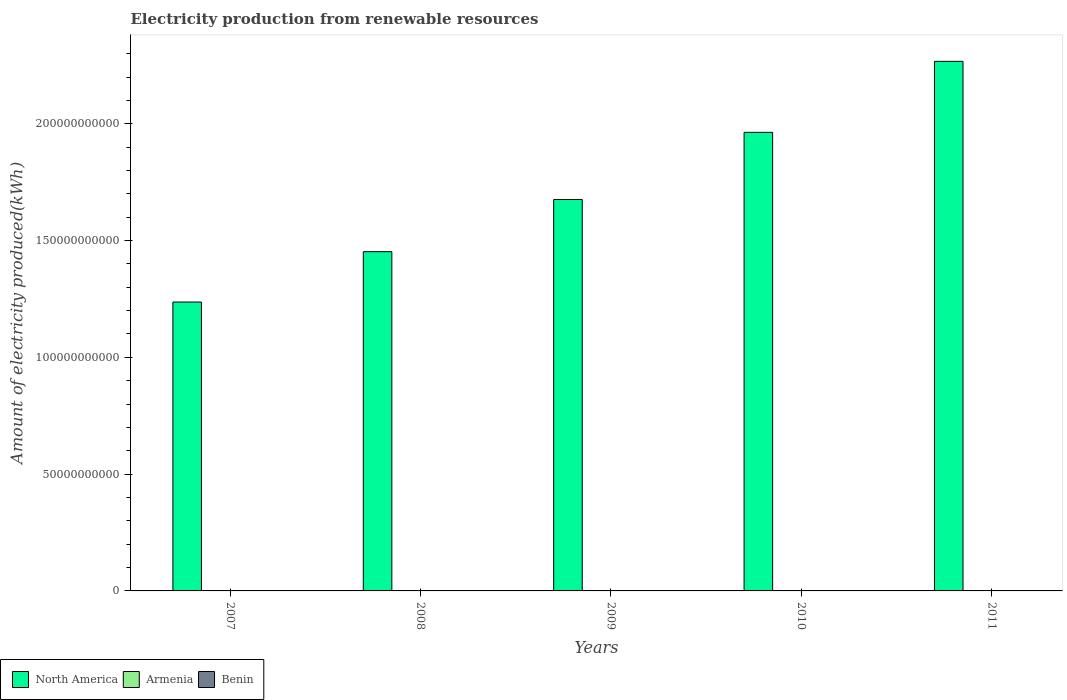How many different coloured bars are there?
Offer a very short reply. 3. Are the number of bars per tick equal to the number of legend labels?
Keep it short and to the point. Yes. How many bars are there on the 2nd tick from the left?
Provide a succinct answer. 3. How many bars are there on the 1st tick from the right?
Provide a short and direct response. 3. What is the label of the 4th group of bars from the left?
Ensure brevity in your answer.  2010. What is the amount of electricity produced in North America in 2009?
Your answer should be very brief. 1.68e+11. Across all years, what is the maximum amount of electricity produced in Armenia?
Your answer should be very brief. 7.00e+06. Across all years, what is the minimum amount of electricity produced in Benin?
Provide a succinct answer. 1.00e+06. In which year was the amount of electricity produced in North America maximum?
Keep it short and to the point. 2011. In which year was the amount of electricity produced in North America minimum?
Ensure brevity in your answer.  2007. What is the total amount of electricity produced in Benin in the graph?
Provide a short and direct response. 9.00e+06. What is the average amount of electricity produced in Benin per year?
Provide a succinct answer. 1.80e+06. In the year 2009, what is the difference between the amount of electricity produced in North America and amount of electricity produced in Benin?
Provide a succinct answer. 1.68e+11. In how many years, is the amount of electricity produced in North America greater than 220000000000 kWh?
Your answer should be very brief. 1. What is the ratio of the amount of electricity produced in Benin in 2010 to that in 2011?
Your answer should be very brief. 1. Is the difference between the amount of electricity produced in North America in 2008 and 2010 greater than the difference between the amount of electricity produced in Benin in 2008 and 2010?
Offer a very short reply. No. What is the difference between the highest and the second highest amount of electricity produced in Armenia?
Provide a short and direct response. 1.00e+06. What is the difference between the highest and the lowest amount of electricity produced in North America?
Make the answer very short. 1.03e+11. What does the 1st bar from the left in 2010 represents?
Offer a terse response. North America. What does the 3rd bar from the right in 2008 represents?
Your response must be concise. North America. How many bars are there?
Make the answer very short. 15. Are the values on the major ticks of Y-axis written in scientific E-notation?
Offer a very short reply. No. Where does the legend appear in the graph?
Keep it short and to the point. Bottom left. How are the legend labels stacked?
Make the answer very short. Horizontal. What is the title of the graph?
Ensure brevity in your answer.  Electricity production from renewable resources. Does "Belarus" appear as one of the legend labels in the graph?
Offer a very short reply. No. What is the label or title of the Y-axis?
Keep it short and to the point. Amount of electricity produced(kWh). What is the Amount of electricity produced(kWh) in North America in 2007?
Your answer should be very brief. 1.24e+11. What is the Amount of electricity produced(kWh) in North America in 2008?
Provide a short and direct response. 1.45e+11. What is the Amount of electricity produced(kWh) of Armenia in 2008?
Ensure brevity in your answer.  2.00e+06. What is the Amount of electricity produced(kWh) in Benin in 2008?
Provide a succinct answer. 3.00e+06. What is the Amount of electricity produced(kWh) in North America in 2009?
Offer a very short reply. 1.68e+11. What is the Amount of electricity produced(kWh) of Benin in 2009?
Provide a short and direct response. 1.00e+06. What is the Amount of electricity produced(kWh) in North America in 2010?
Your response must be concise. 1.96e+11. What is the Amount of electricity produced(kWh) in North America in 2011?
Give a very brief answer. 2.27e+11. What is the Amount of electricity produced(kWh) of Benin in 2011?
Offer a terse response. 1.00e+06. Across all years, what is the maximum Amount of electricity produced(kWh) of North America?
Your response must be concise. 2.27e+11. Across all years, what is the maximum Amount of electricity produced(kWh) in Armenia?
Keep it short and to the point. 7.00e+06. Across all years, what is the maximum Amount of electricity produced(kWh) in Benin?
Your answer should be very brief. 3.00e+06. Across all years, what is the minimum Amount of electricity produced(kWh) in North America?
Keep it short and to the point. 1.24e+11. What is the total Amount of electricity produced(kWh) of North America in the graph?
Ensure brevity in your answer.  8.60e+11. What is the total Amount of electricity produced(kWh) of Armenia in the graph?
Offer a very short reply. 2.20e+07. What is the total Amount of electricity produced(kWh) in Benin in the graph?
Give a very brief answer. 9.00e+06. What is the difference between the Amount of electricity produced(kWh) in North America in 2007 and that in 2008?
Give a very brief answer. -2.16e+1. What is the difference between the Amount of electricity produced(kWh) in North America in 2007 and that in 2009?
Give a very brief answer. -4.39e+1. What is the difference between the Amount of electricity produced(kWh) of North America in 2007 and that in 2010?
Provide a short and direct response. -7.26e+1. What is the difference between the Amount of electricity produced(kWh) in Armenia in 2007 and that in 2010?
Make the answer very short. -4.00e+06. What is the difference between the Amount of electricity produced(kWh) in North America in 2007 and that in 2011?
Provide a short and direct response. -1.03e+11. What is the difference between the Amount of electricity produced(kWh) of North America in 2008 and that in 2009?
Offer a very short reply. -2.23e+1. What is the difference between the Amount of electricity produced(kWh) of Armenia in 2008 and that in 2009?
Make the answer very short. -2.00e+06. What is the difference between the Amount of electricity produced(kWh) in North America in 2008 and that in 2010?
Provide a succinct answer. -5.11e+1. What is the difference between the Amount of electricity produced(kWh) of Armenia in 2008 and that in 2010?
Make the answer very short. -5.00e+06. What is the difference between the Amount of electricity produced(kWh) in North America in 2008 and that in 2011?
Your answer should be compact. -8.15e+1. What is the difference between the Amount of electricity produced(kWh) in North America in 2009 and that in 2010?
Offer a terse response. -2.87e+1. What is the difference between the Amount of electricity produced(kWh) of Armenia in 2009 and that in 2010?
Offer a terse response. -3.00e+06. What is the difference between the Amount of electricity produced(kWh) in North America in 2009 and that in 2011?
Ensure brevity in your answer.  -5.91e+1. What is the difference between the Amount of electricity produced(kWh) in Benin in 2009 and that in 2011?
Keep it short and to the point. 0. What is the difference between the Amount of electricity produced(kWh) in North America in 2010 and that in 2011?
Your answer should be very brief. -3.04e+1. What is the difference between the Amount of electricity produced(kWh) in Armenia in 2010 and that in 2011?
Provide a succinct answer. 1.00e+06. What is the difference between the Amount of electricity produced(kWh) in North America in 2007 and the Amount of electricity produced(kWh) in Armenia in 2008?
Give a very brief answer. 1.24e+11. What is the difference between the Amount of electricity produced(kWh) in North America in 2007 and the Amount of electricity produced(kWh) in Benin in 2008?
Offer a terse response. 1.24e+11. What is the difference between the Amount of electricity produced(kWh) in Armenia in 2007 and the Amount of electricity produced(kWh) in Benin in 2008?
Ensure brevity in your answer.  0. What is the difference between the Amount of electricity produced(kWh) in North America in 2007 and the Amount of electricity produced(kWh) in Armenia in 2009?
Your response must be concise. 1.24e+11. What is the difference between the Amount of electricity produced(kWh) in North America in 2007 and the Amount of electricity produced(kWh) in Benin in 2009?
Offer a very short reply. 1.24e+11. What is the difference between the Amount of electricity produced(kWh) of Armenia in 2007 and the Amount of electricity produced(kWh) of Benin in 2009?
Make the answer very short. 2.00e+06. What is the difference between the Amount of electricity produced(kWh) in North America in 2007 and the Amount of electricity produced(kWh) in Armenia in 2010?
Keep it short and to the point. 1.24e+11. What is the difference between the Amount of electricity produced(kWh) in North America in 2007 and the Amount of electricity produced(kWh) in Benin in 2010?
Your answer should be compact. 1.24e+11. What is the difference between the Amount of electricity produced(kWh) in Armenia in 2007 and the Amount of electricity produced(kWh) in Benin in 2010?
Your answer should be compact. 2.00e+06. What is the difference between the Amount of electricity produced(kWh) in North America in 2007 and the Amount of electricity produced(kWh) in Armenia in 2011?
Give a very brief answer. 1.24e+11. What is the difference between the Amount of electricity produced(kWh) in North America in 2007 and the Amount of electricity produced(kWh) in Benin in 2011?
Your answer should be very brief. 1.24e+11. What is the difference between the Amount of electricity produced(kWh) of North America in 2008 and the Amount of electricity produced(kWh) of Armenia in 2009?
Your answer should be very brief. 1.45e+11. What is the difference between the Amount of electricity produced(kWh) in North America in 2008 and the Amount of electricity produced(kWh) in Benin in 2009?
Your answer should be compact. 1.45e+11. What is the difference between the Amount of electricity produced(kWh) of Armenia in 2008 and the Amount of electricity produced(kWh) of Benin in 2009?
Keep it short and to the point. 1.00e+06. What is the difference between the Amount of electricity produced(kWh) in North America in 2008 and the Amount of electricity produced(kWh) in Armenia in 2010?
Provide a succinct answer. 1.45e+11. What is the difference between the Amount of electricity produced(kWh) in North America in 2008 and the Amount of electricity produced(kWh) in Benin in 2010?
Give a very brief answer. 1.45e+11. What is the difference between the Amount of electricity produced(kWh) in Armenia in 2008 and the Amount of electricity produced(kWh) in Benin in 2010?
Ensure brevity in your answer.  1.00e+06. What is the difference between the Amount of electricity produced(kWh) in North America in 2008 and the Amount of electricity produced(kWh) in Armenia in 2011?
Give a very brief answer. 1.45e+11. What is the difference between the Amount of electricity produced(kWh) of North America in 2008 and the Amount of electricity produced(kWh) of Benin in 2011?
Your response must be concise. 1.45e+11. What is the difference between the Amount of electricity produced(kWh) of North America in 2009 and the Amount of electricity produced(kWh) of Armenia in 2010?
Keep it short and to the point. 1.68e+11. What is the difference between the Amount of electricity produced(kWh) of North America in 2009 and the Amount of electricity produced(kWh) of Benin in 2010?
Your answer should be compact. 1.68e+11. What is the difference between the Amount of electricity produced(kWh) of Armenia in 2009 and the Amount of electricity produced(kWh) of Benin in 2010?
Your response must be concise. 3.00e+06. What is the difference between the Amount of electricity produced(kWh) in North America in 2009 and the Amount of electricity produced(kWh) in Armenia in 2011?
Offer a terse response. 1.68e+11. What is the difference between the Amount of electricity produced(kWh) of North America in 2009 and the Amount of electricity produced(kWh) of Benin in 2011?
Offer a terse response. 1.68e+11. What is the difference between the Amount of electricity produced(kWh) of Armenia in 2009 and the Amount of electricity produced(kWh) of Benin in 2011?
Give a very brief answer. 3.00e+06. What is the difference between the Amount of electricity produced(kWh) in North America in 2010 and the Amount of electricity produced(kWh) in Armenia in 2011?
Provide a short and direct response. 1.96e+11. What is the difference between the Amount of electricity produced(kWh) of North America in 2010 and the Amount of electricity produced(kWh) of Benin in 2011?
Make the answer very short. 1.96e+11. What is the difference between the Amount of electricity produced(kWh) in Armenia in 2010 and the Amount of electricity produced(kWh) in Benin in 2011?
Provide a short and direct response. 6.00e+06. What is the average Amount of electricity produced(kWh) of North America per year?
Offer a terse response. 1.72e+11. What is the average Amount of electricity produced(kWh) of Armenia per year?
Your answer should be very brief. 4.40e+06. What is the average Amount of electricity produced(kWh) of Benin per year?
Ensure brevity in your answer.  1.80e+06. In the year 2007, what is the difference between the Amount of electricity produced(kWh) of North America and Amount of electricity produced(kWh) of Armenia?
Your response must be concise. 1.24e+11. In the year 2007, what is the difference between the Amount of electricity produced(kWh) in North America and Amount of electricity produced(kWh) in Benin?
Give a very brief answer. 1.24e+11. In the year 2007, what is the difference between the Amount of electricity produced(kWh) in Armenia and Amount of electricity produced(kWh) in Benin?
Keep it short and to the point. 0. In the year 2008, what is the difference between the Amount of electricity produced(kWh) of North America and Amount of electricity produced(kWh) of Armenia?
Offer a terse response. 1.45e+11. In the year 2008, what is the difference between the Amount of electricity produced(kWh) of North America and Amount of electricity produced(kWh) of Benin?
Your answer should be very brief. 1.45e+11. In the year 2008, what is the difference between the Amount of electricity produced(kWh) in Armenia and Amount of electricity produced(kWh) in Benin?
Your answer should be compact. -1.00e+06. In the year 2009, what is the difference between the Amount of electricity produced(kWh) in North America and Amount of electricity produced(kWh) in Armenia?
Ensure brevity in your answer.  1.68e+11. In the year 2009, what is the difference between the Amount of electricity produced(kWh) in North America and Amount of electricity produced(kWh) in Benin?
Provide a short and direct response. 1.68e+11. In the year 2009, what is the difference between the Amount of electricity produced(kWh) in Armenia and Amount of electricity produced(kWh) in Benin?
Give a very brief answer. 3.00e+06. In the year 2010, what is the difference between the Amount of electricity produced(kWh) of North America and Amount of electricity produced(kWh) of Armenia?
Your response must be concise. 1.96e+11. In the year 2010, what is the difference between the Amount of electricity produced(kWh) of North America and Amount of electricity produced(kWh) of Benin?
Offer a terse response. 1.96e+11. In the year 2011, what is the difference between the Amount of electricity produced(kWh) in North America and Amount of electricity produced(kWh) in Armenia?
Offer a terse response. 2.27e+11. In the year 2011, what is the difference between the Amount of electricity produced(kWh) in North America and Amount of electricity produced(kWh) in Benin?
Offer a very short reply. 2.27e+11. What is the ratio of the Amount of electricity produced(kWh) of North America in 2007 to that in 2008?
Keep it short and to the point. 0.85. What is the ratio of the Amount of electricity produced(kWh) of North America in 2007 to that in 2009?
Give a very brief answer. 0.74. What is the ratio of the Amount of electricity produced(kWh) of Benin in 2007 to that in 2009?
Offer a very short reply. 3. What is the ratio of the Amount of electricity produced(kWh) of North America in 2007 to that in 2010?
Keep it short and to the point. 0.63. What is the ratio of the Amount of electricity produced(kWh) of Armenia in 2007 to that in 2010?
Provide a short and direct response. 0.43. What is the ratio of the Amount of electricity produced(kWh) in Benin in 2007 to that in 2010?
Keep it short and to the point. 3. What is the ratio of the Amount of electricity produced(kWh) of North America in 2007 to that in 2011?
Your answer should be very brief. 0.55. What is the ratio of the Amount of electricity produced(kWh) of Armenia in 2007 to that in 2011?
Offer a very short reply. 0.5. What is the ratio of the Amount of electricity produced(kWh) in Benin in 2007 to that in 2011?
Offer a terse response. 3. What is the ratio of the Amount of electricity produced(kWh) in North America in 2008 to that in 2009?
Provide a succinct answer. 0.87. What is the ratio of the Amount of electricity produced(kWh) in Armenia in 2008 to that in 2009?
Keep it short and to the point. 0.5. What is the ratio of the Amount of electricity produced(kWh) in North America in 2008 to that in 2010?
Offer a very short reply. 0.74. What is the ratio of the Amount of electricity produced(kWh) of Armenia in 2008 to that in 2010?
Ensure brevity in your answer.  0.29. What is the ratio of the Amount of electricity produced(kWh) of Benin in 2008 to that in 2010?
Provide a short and direct response. 3. What is the ratio of the Amount of electricity produced(kWh) of North America in 2008 to that in 2011?
Your response must be concise. 0.64. What is the ratio of the Amount of electricity produced(kWh) in North America in 2009 to that in 2010?
Provide a succinct answer. 0.85. What is the ratio of the Amount of electricity produced(kWh) of Armenia in 2009 to that in 2010?
Your answer should be very brief. 0.57. What is the ratio of the Amount of electricity produced(kWh) in Benin in 2009 to that in 2010?
Offer a terse response. 1. What is the ratio of the Amount of electricity produced(kWh) of North America in 2009 to that in 2011?
Make the answer very short. 0.74. What is the ratio of the Amount of electricity produced(kWh) in Armenia in 2009 to that in 2011?
Your answer should be very brief. 0.67. What is the ratio of the Amount of electricity produced(kWh) in North America in 2010 to that in 2011?
Your answer should be very brief. 0.87. What is the ratio of the Amount of electricity produced(kWh) of Armenia in 2010 to that in 2011?
Provide a short and direct response. 1.17. What is the ratio of the Amount of electricity produced(kWh) in Benin in 2010 to that in 2011?
Keep it short and to the point. 1. What is the difference between the highest and the second highest Amount of electricity produced(kWh) of North America?
Offer a very short reply. 3.04e+1. What is the difference between the highest and the second highest Amount of electricity produced(kWh) in Armenia?
Your response must be concise. 1.00e+06. What is the difference between the highest and the second highest Amount of electricity produced(kWh) of Benin?
Your answer should be compact. 0. What is the difference between the highest and the lowest Amount of electricity produced(kWh) in North America?
Provide a short and direct response. 1.03e+11. What is the difference between the highest and the lowest Amount of electricity produced(kWh) of Benin?
Your response must be concise. 2.00e+06. 